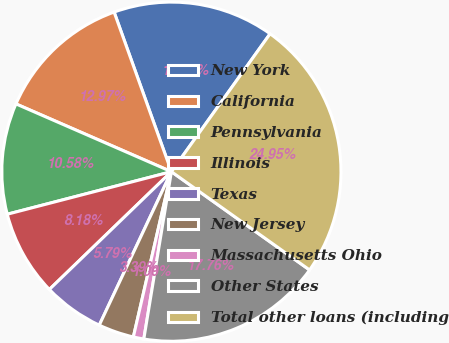<chart> <loc_0><loc_0><loc_500><loc_500><pie_chart><fcel>New York<fcel>California<fcel>Pennsylvania<fcel>Illinois<fcel>Texas<fcel>New Jersey<fcel>Massachusetts Ohio<fcel>Other States<fcel>Total other loans (including<nl><fcel>15.37%<fcel>12.97%<fcel>10.58%<fcel>8.18%<fcel>5.79%<fcel>3.39%<fcel>1.0%<fcel>17.76%<fcel>24.95%<nl></chart> 